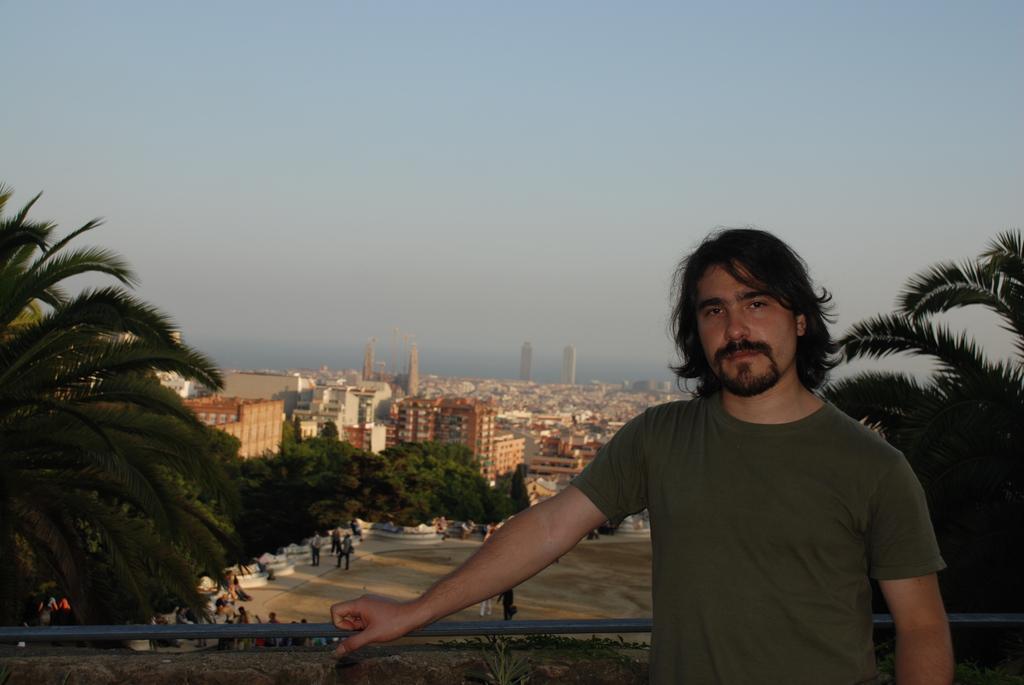How would you summarize this image in a sentence or two? In this image there is a person standing, in the background there are trees, buildings and the sky. 